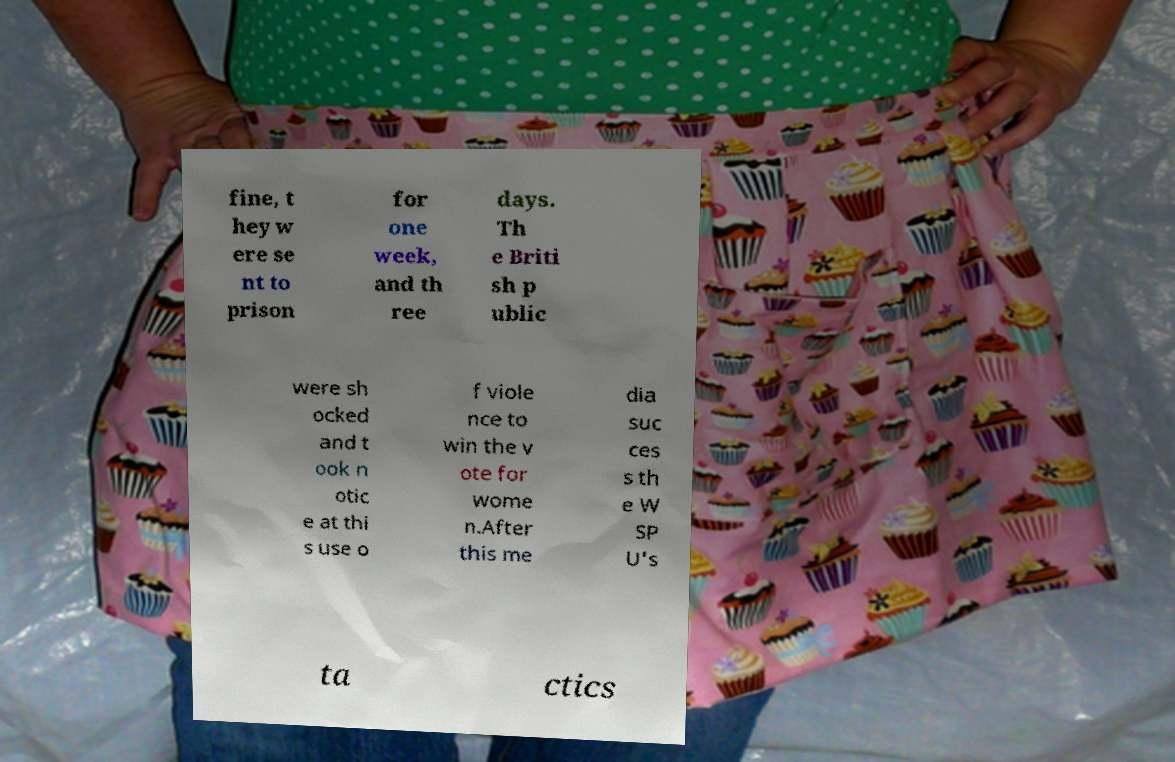Please read and relay the text visible in this image. What does it say? fine, t hey w ere se nt to prison for one week, and th ree days. Th e Briti sh p ublic were sh ocked and t ook n otic e at thi s use o f viole nce to win the v ote for wome n.After this me dia suc ces s th e W SP U's ta ctics 